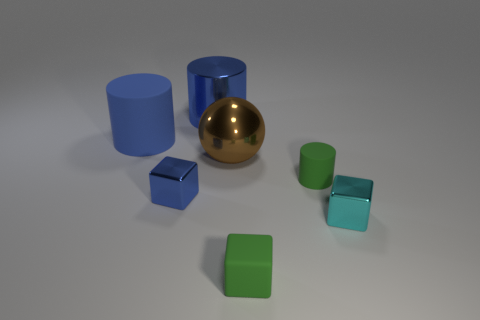Add 1 blue objects. How many objects exist? 8 Subtract all green cylinders. How many cylinders are left? 2 Subtract all blue cylinders. How many cylinders are left? 1 Subtract all cylinders. How many objects are left? 4 Subtract 3 blocks. How many blocks are left? 0 Subtract all cyan cylinders. Subtract all purple spheres. How many cylinders are left? 3 Subtract all yellow cylinders. How many red blocks are left? 0 Subtract all tiny metallic objects. Subtract all cyan metal objects. How many objects are left? 4 Add 5 large rubber cylinders. How many large rubber cylinders are left? 6 Add 2 tiny matte objects. How many tiny matte objects exist? 4 